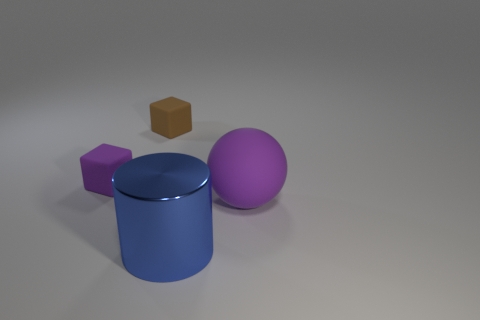There is a small thing that is the same color as the large rubber object; what is its shape?
Your response must be concise. Cube. There is a purple object that is the same shape as the tiny brown object; what material is it?
Your answer should be very brief. Rubber. Do the big ball and the blue cylinder have the same material?
Provide a short and direct response. No. Are there more rubber spheres that are left of the big blue metallic cylinder than large blue cylinders?
Offer a very short reply. No. What material is the thing on the right side of the thing in front of the purple object on the right side of the large blue metal thing?
Offer a very short reply. Rubber. What number of objects are either small purple matte things or cubes that are in front of the brown rubber object?
Provide a short and direct response. 1. Is the color of the cube that is in front of the brown rubber block the same as the large cylinder?
Offer a very short reply. No. Is the number of large purple matte balls that are in front of the blue object greater than the number of purple matte balls that are to the left of the purple rubber block?
Ensure brevity in your answer.  No. Is there anything else that has the same color as the rubber ball?
Provide a short and direct response. Yes. What number of things are large red spheres or matte blocks?
Provide a succinct answer. 2. 